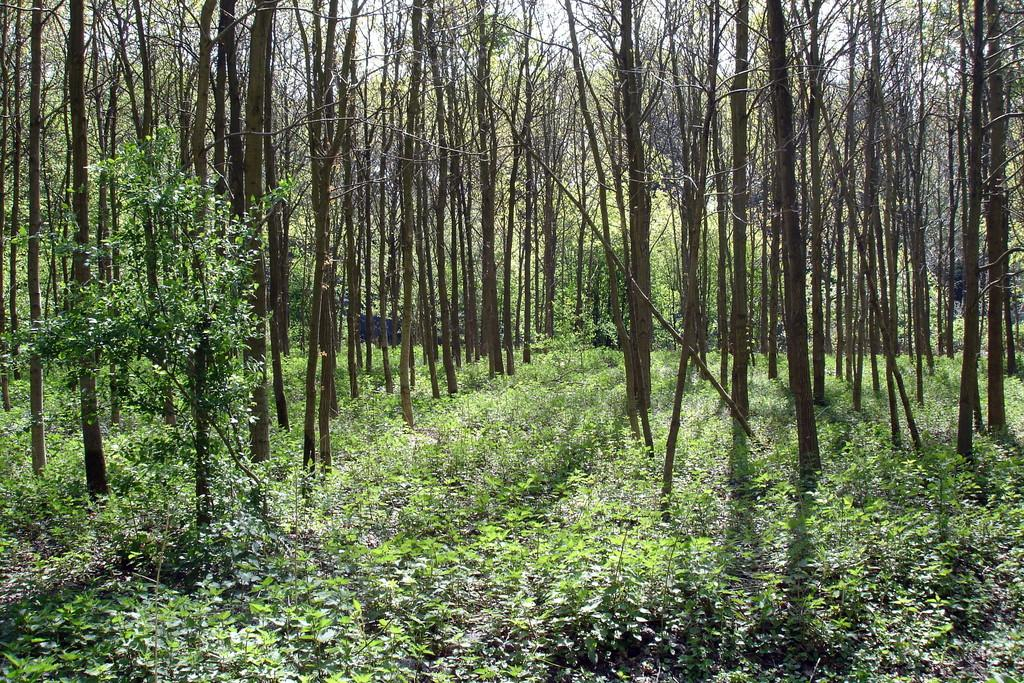What type of vegetation can be seen in the image? There are many trees, plants, and grass in the image. What part of the natural environment is visible in the image? The sky is visible at the top of the image, and leaves are present at the bottom of the image. What type of fruit can be seen hanging from the trees in the image? There is no fruit visible in the image; only trees, plants, grass, and leaves are present. 